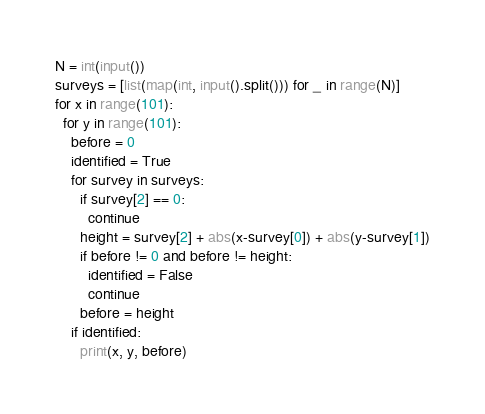<code> <loc_0><loc_0><loc_500><loc_500><_Python_>N = int(input())
surveys = [list(map(int, input().split())) for _ in range(N)]
for x in range(101):
  for y in range(101):
    before = 0
    identified = True
    for survey in surveys:
      if survey[2] == 0:
        continue
      height = survey[2] + abs(x-survey[0]) + abs(y-survey[1])
      if before != 0 and before != height:
        identified = False
        continue
      before = height
    if identified:
      print(x, y, before)</code> 